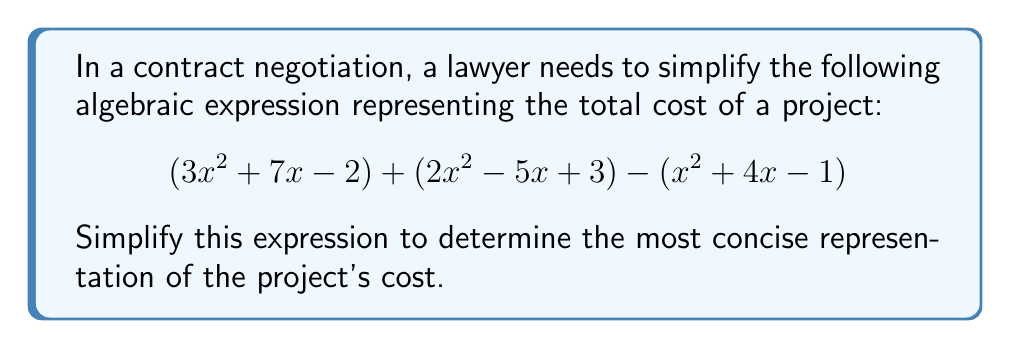Solve this math problem. Let's approach this step-by-step:

1) First, we'll group like terms. We have three groups of terms: $x^2$ terms, $x$ terms, and constant terms.

2) For $x^2$ terms:
   $3x^2 + 2x^2 - x^2 = 4x^2$

3) For $x$ terms:
   $7x - 5x - 4x = -2x$

4) For constant terms:
   $-2 + 3 + 1 = 2$

5) Now, we can combine these simplified terms:
   $$4x^2 - 2x + 2$$

This simplified expression represents the most concise form of the project's cost.
Answer: $4x^2 - 2x + 2$ 